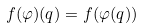<formula> <loc_0><loc_0><loc_500><loc_500>f ( \varphi ) ( q ) = f ( \varphi ( q ) )</formula> 